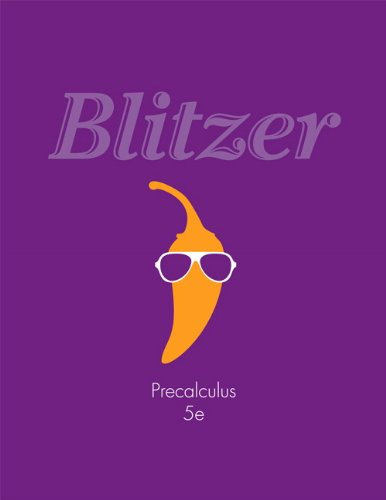Who is the author of this book? The author of this textbook is Robert F. Blitzer, who is known for integrating his proven pedagogy with a clear and friendly writing style. 